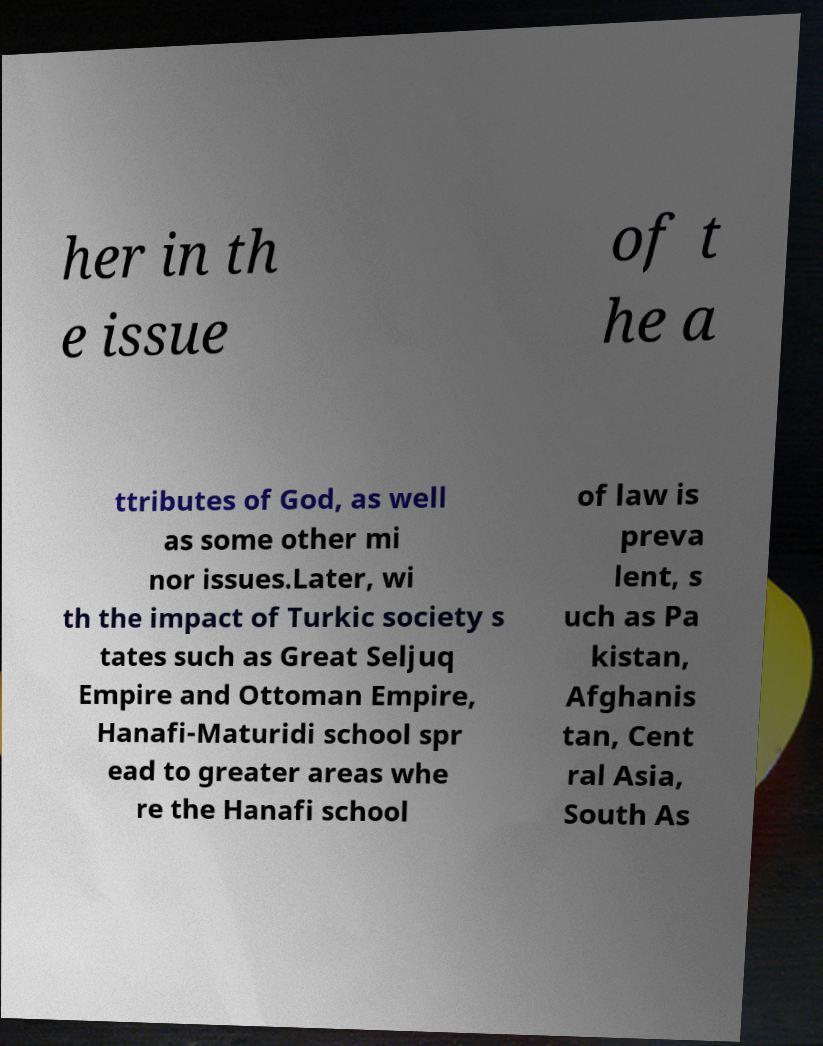I need the written content from this picture converted into text. Can you do that? her in th e issue of t he a ttributes of God, as well as some other mi nor issues.Later, wi th the impact of Turkic society s tates such as Great Seljuq Empire and Ottoman Empire, Hanafi-Maturidi school spr ead to greater areas whe re the Hanafi school of law is preva lent, s uch as Pa kistan, Afghanis tan, Cent ral Asia, South As 